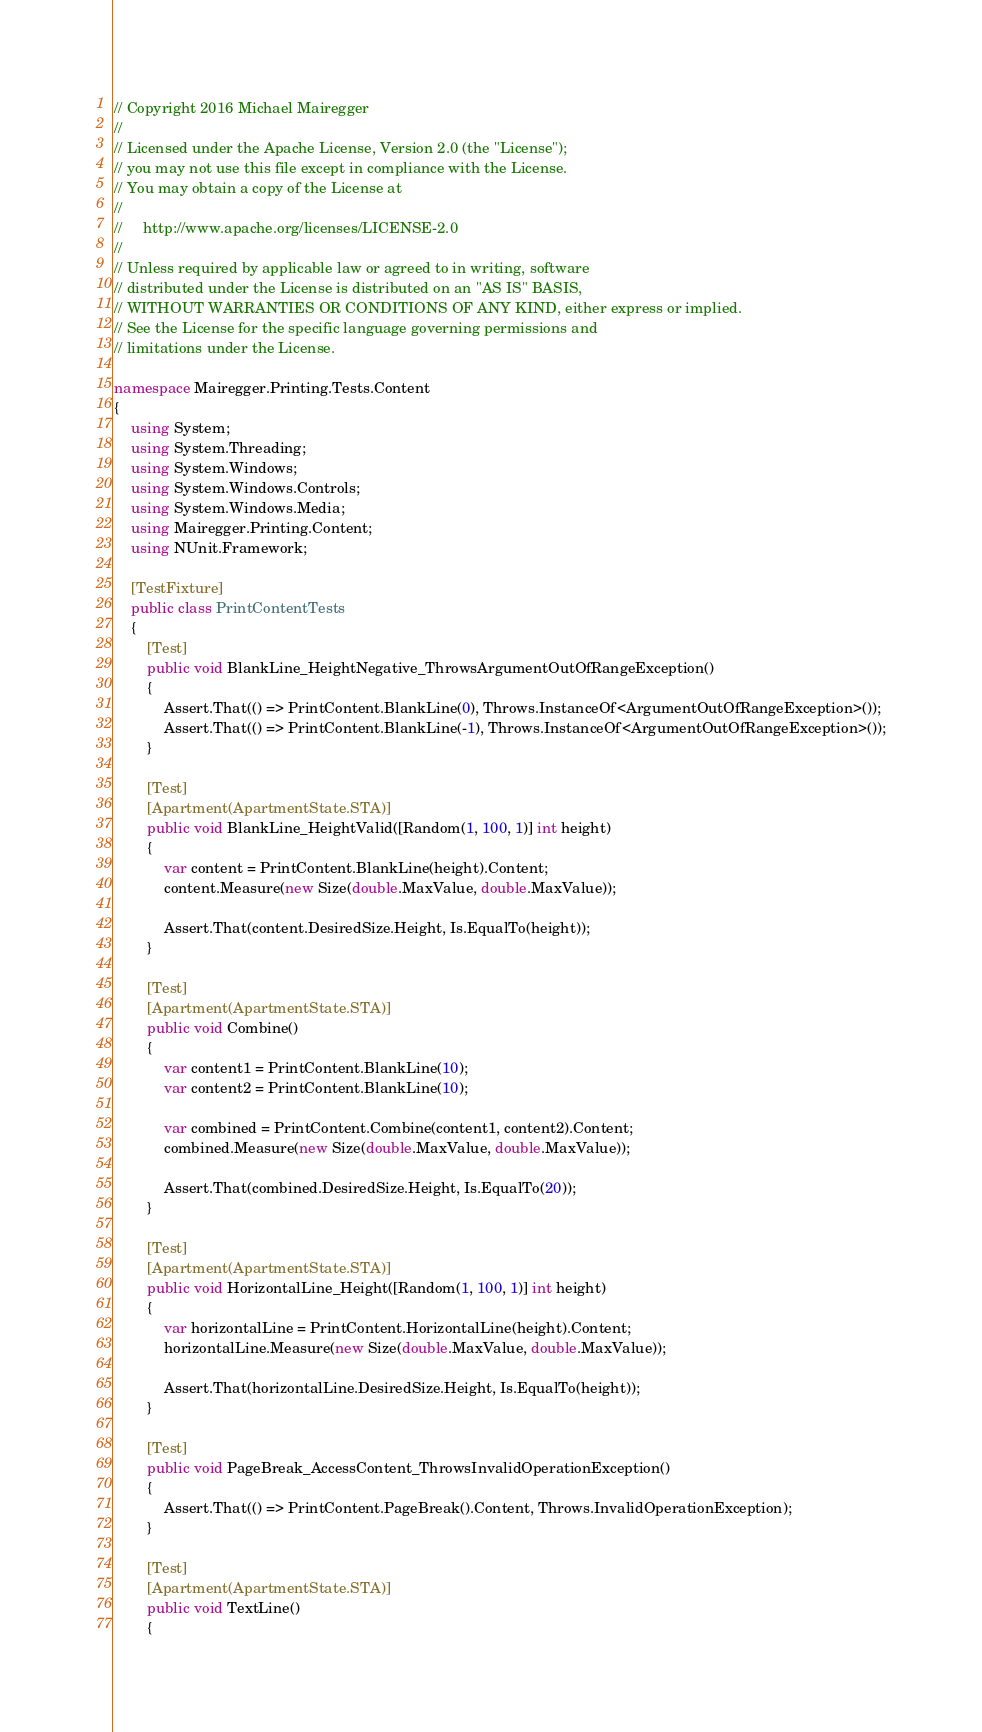<code> <loc_0><loc_0><loc_500><loc_500><_C#_>// Copyright 2016 Michael Mairegger
// 
// Licensed under the Apache License, Version 2.0 (the "License");
// you may not use this file except in compliance with the License.
// You may obtain a copy of the License at
// 
//     http://www.apache.org/licenses/LICENSE-2.0
// 
// Unless required by applicable law or agreed to in writing, software
// distributed under the License is distributed on an "AS IS" BASIS,
// WITHOUT WARRANTIES OR CONDITIONS OF ANY KIND, either express or implied.
// See the License for the specific language governing permissions and
// limitations under the License.

namespace Mairegger.Printing.Tests.Content
{
    using System;
    using System.Threading;
    using System.Windows;
    using System.Windows.Controls;
    using System.Windows.Media;
    using Mairegger.Printing.Content;
    using NUnit.Framework;

    [TestFixture]
    public class PrintContentTests
    {
        [Test]
        public void BlankLine_HeightNegative_ThrowsArgumentOutOfRangeException()
        {
            Assert.That(() => PrintContent.BlankLine(0), Throws.InstanceOf<ArgumentOutOfRangeException>());
            Assert.That(() => PrintContent.BlankLine(-1), Throws.InstanceOf<ArgumentOutOfRangeException>());
        }

        [Test]
        [Apartment(ApartmentState.STA)]
        public void BlankLine_HeightValid([Random(1, 100, 1)] int height)
        {
            var content = PrintContent.BlankLine(height).Content;
            content.Measure(new Size(double.MaxValue, double.MaxValue));

            Assert.That(content.DesiredSize.Height, Is.EqualTo(height));
        }

        [Test]
        [Apartment(ApartmentState.STA)]
        public void Combine()
        {
            var content1 = PrintContent.BlankLine(10);
            var content2 = PrintContent.BlankLine(10);

            var combined = PrintContent.Combine(content1, content2).Content;
            combined.Measure(new Size(double.MaxValue, double.MaxValue));

            Assert.That(combined.DesiredSize.Height, Is.EqualTo(20));
        }

        [Test]
        [Apartment(ApartmentState.STA)]
        public void HorizontalLine_Height([Random(1, 100, 1)] int height)
        {
            var horizontalLine = PrintContent.HorizontalLine(height).Content;
            horizontalLine.Measure(new Size(double.MaxValue, double.MaxValue));

            Assert.That(horizontalLine.DesiredSize.Height, Is.EqualTo(height));
        }

        [Test]
        public void PageBreak_AccessContent_ThrowsInvalidOperationException()
        {
            Assert.That(() => PrintContent.PageBreak().Content, Throws.InvalidOperationException);
        }

        [Test]
        [Apartment(ApartmentState.STA)]
        public void TextLine()
        {</code> 